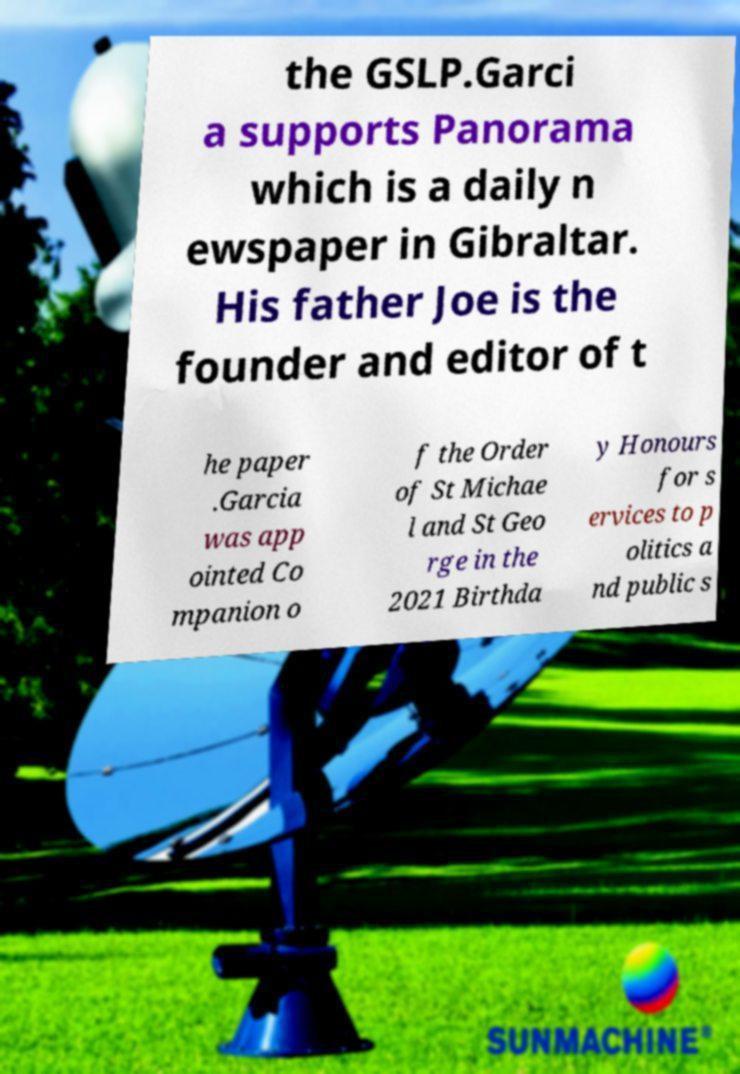What messages or text are displayed in this image? I need them in a readable, typed format. the GSLP.Garci a supports Panorama which is a daily n ewspaper in Gibraltar. His father Joe is the founder and editor of t he paper .Garcia was app ointed Co mpanion o f the Order of St Michae l and St Geo rge in the 2021 Birthda y Honours for s ervices to p olitics a nd public s 